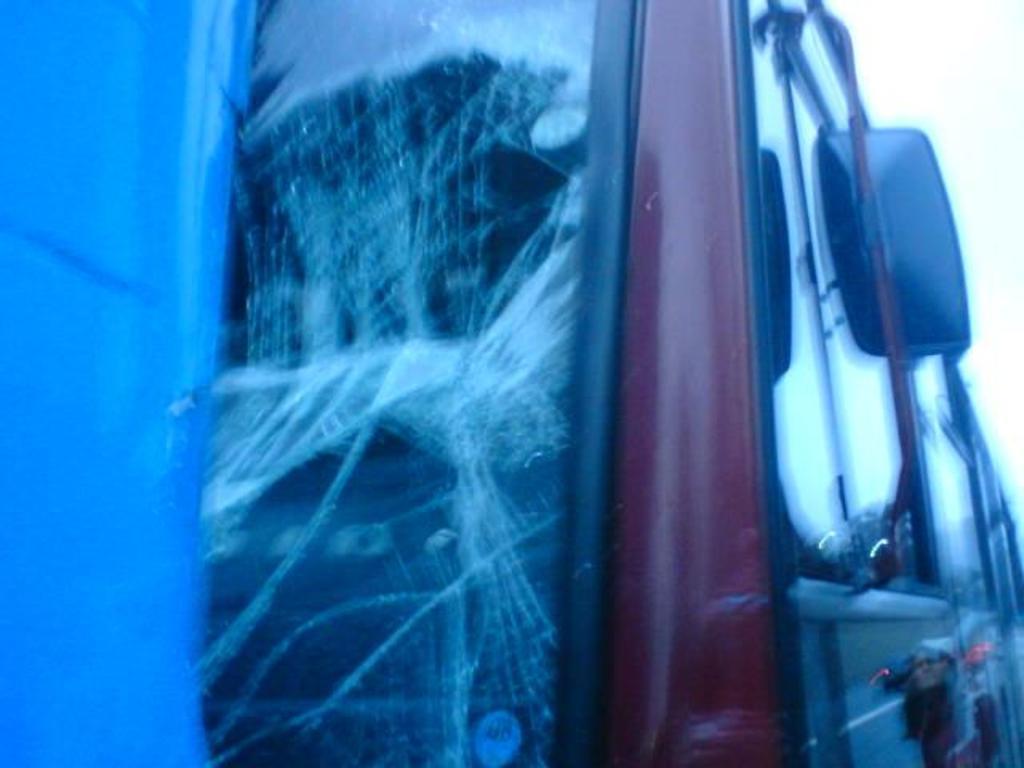Describe this image in one or two sentences. In this picture it looks like a blur image of a vehicle with a broken window glass. 